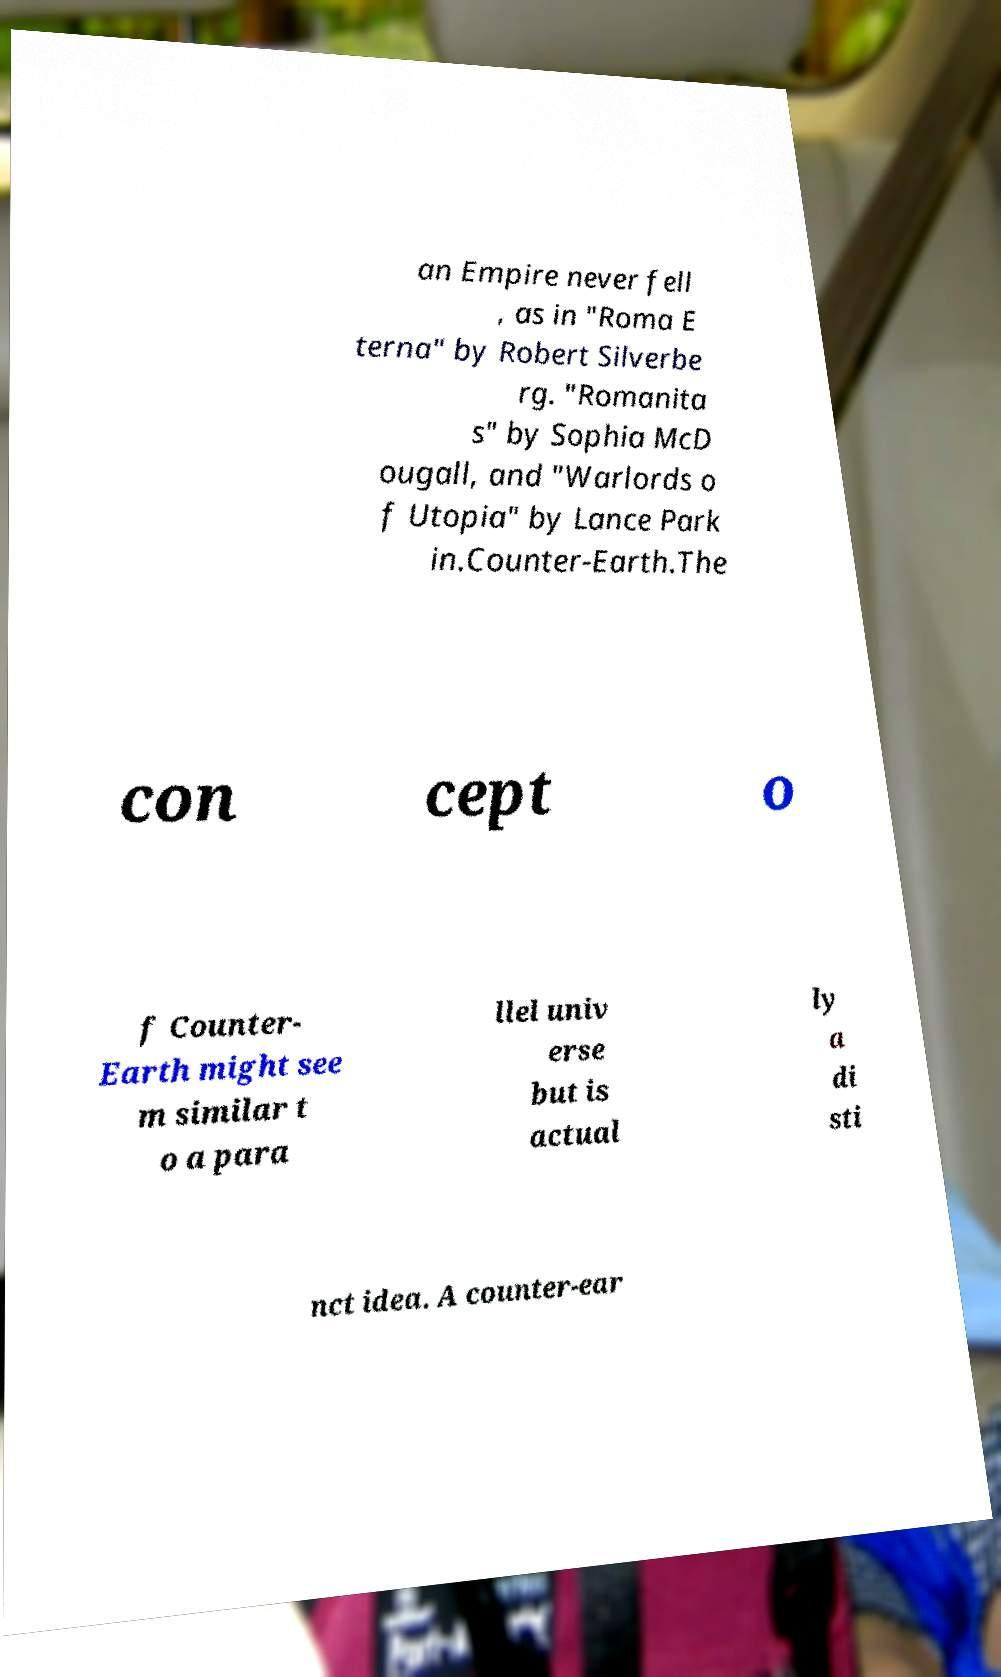I need the written content from this picture converted into text. Can you do that? an Empire never fell , as in "Roma E terna" by Robert Silverbe rg. "Romanita s" by Sophia McD ougall, and "Warlords o f Utopia" by Lance Park in.Counter-Earth.The con cept o f Counter- Earth might see m similar t o a para llel univ erse but is actual ly a di sti nct idea. A counter-ear 